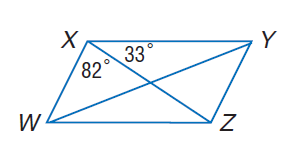Question: W X Y Z is a parallelogram. Find m \angle X W Z.
Choices:
A. 33
B. 65
C. 82
D. 115
Answer with the letter. Answer: B Question: W X Y Z is a parallelogram. Find m \angle Y Z W.
Choices:
A. 33
B. 65
C. 82
D. 115
Answer with the letter. Answer: D 